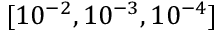<formula> <loc_0><loc_0><loc_500><loc_500>[ 1 0 ^ { - 2 } , 1 0 ^ { - 3 } , 1 0 ^ { - 4 } ]</formula> 